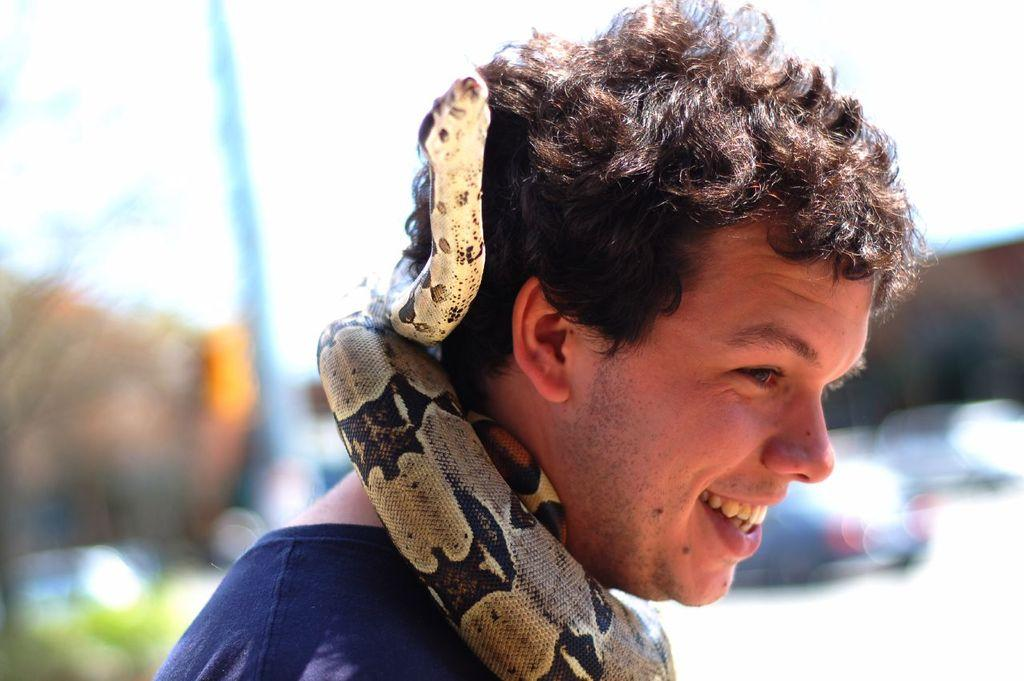Who is present in the image? There is a man in the image. What is the man holding or wearing in the image? A snake is wrapped around the man's neck. What can be seen in the background of the image? There is a tree and vehicles in the background of the image. What is the man's temper like on the stage in the image? There is no stage present in the image, and the man's temper cannot be determined from the image. What type of industry is depicted in the image? The image does not depict any specific industry; it features a man with a snake and a background with a tree and vehicles. 